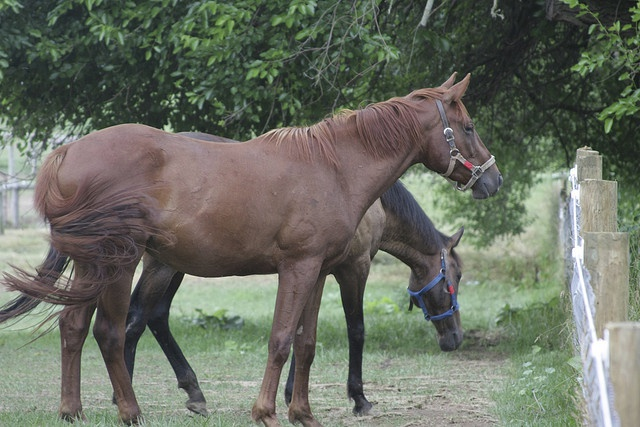Describe the objects in this image and their specific colors. I can see horse in darkgreen, gray, and black tones and horse in darkgreen, gray, black, and darkgray tones in this image. 